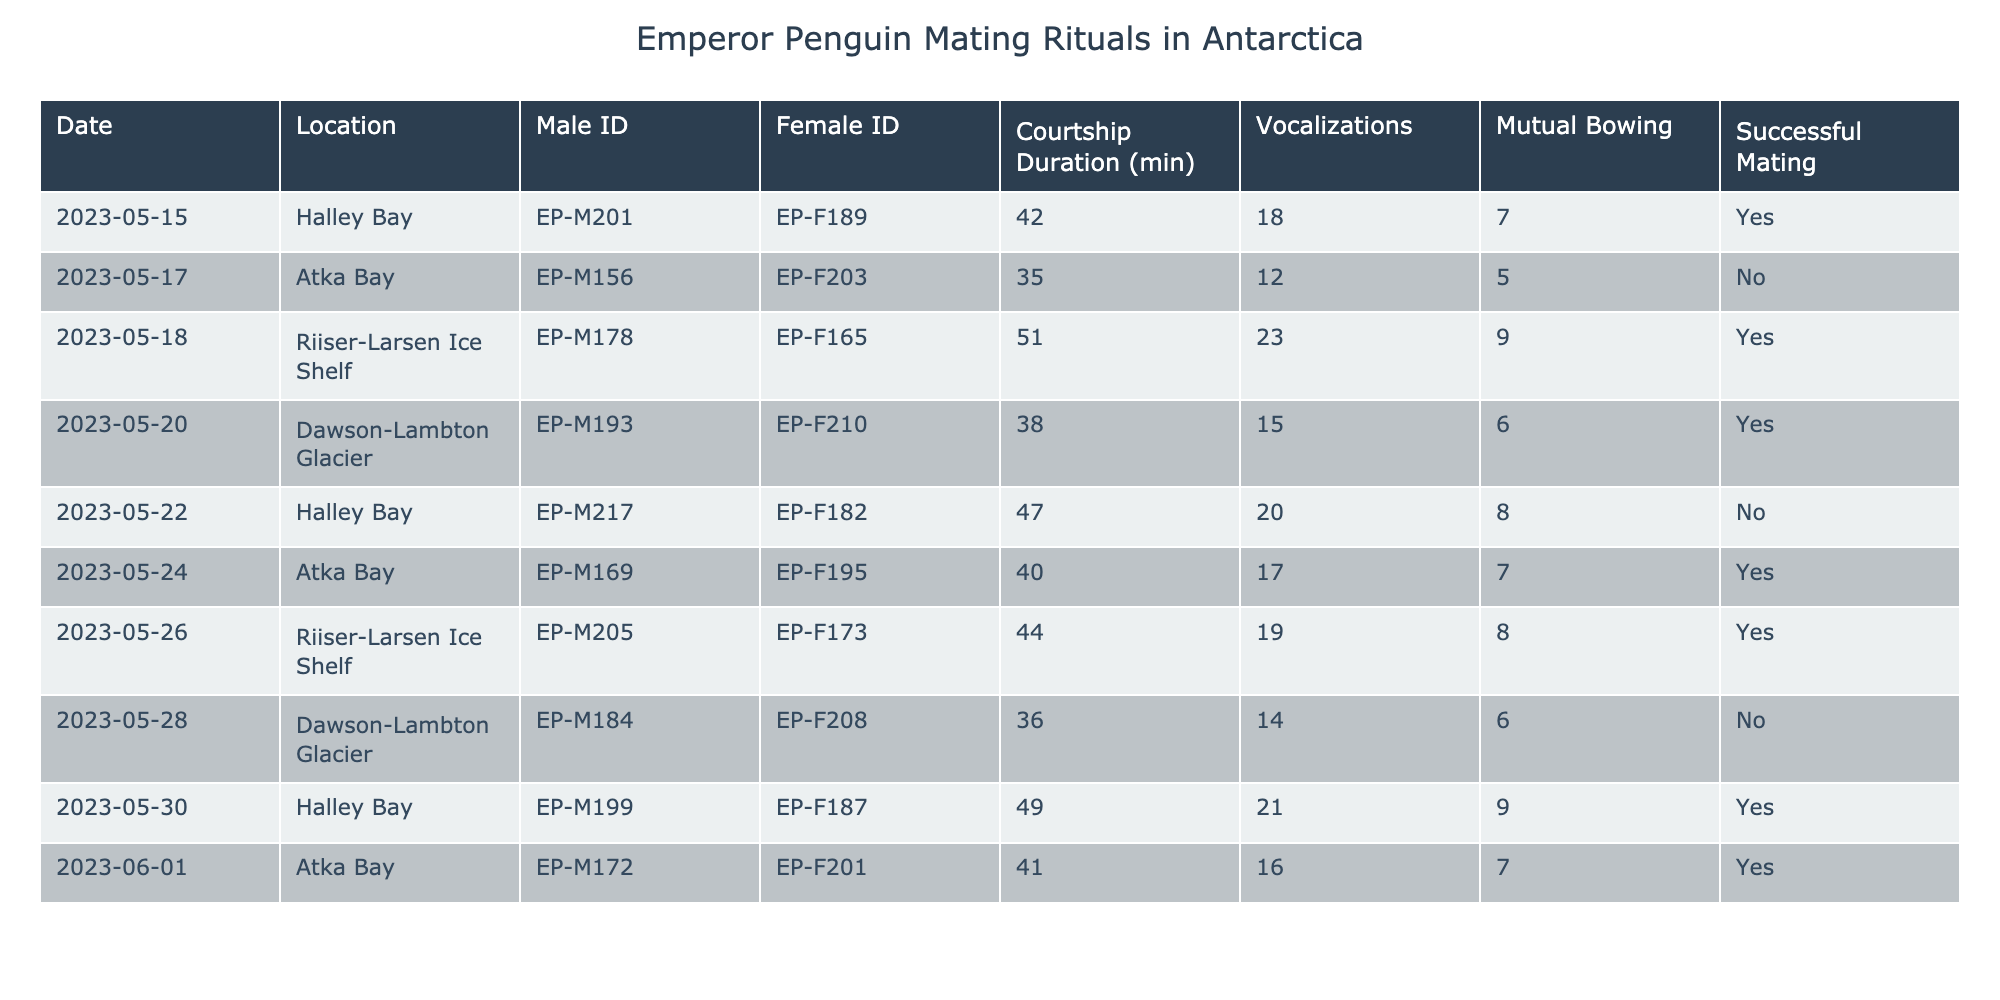What is the courtship duration for the mating pair on May 18? The courtship duration for the mating pair on May 18 is specifically listed in the table under that date, which shows a duration of 51 minutes.
Answer: 51 minutes How many successful mating attempts were observed? By counting the rows in the table where the "Successful Mating" column has the value "Yes," there are 6 rows with successful mating attempts.
Answer: 6 What was the maximum number of vocalizations recorded in a single mating ritual? The "Vocalizations" column indicates the number of vocalizations for each entry, and the highest value in this column is 23, recorded on May 18.
Answer: 23 Did any mating rituals have a courtship duration of less than 40 minutes? By examining the "Courtship Duration" column, the entries for May 17 (35 min) and May 28 (36 min) show courtship durations under 40 minutes, confirming that there were instances of shorter durations.
Answer: Yes What is the average courtship duration for successfully mated pairs? From the pairs that successfully mated (6 instances), the durations are 42, 51, 38, 44, 49, and 41 minutes. Adding these gives 261 minutes, and dividing by 6 gives an average of 43.5 minutes.
Answer: 43.5 minutes How many mutual bowing events occurred during successful mating? By examining the "Mutual Bowing" column for rows with "Yes" in "Successful Mating," we find the mutual bowing counts: 7, 9, 6, 8, 9, and 7. Summing these values results in a total of 46 mutual bowing events during successful matings.
Answer: 46 Is there any female ID that was involved in mating with more than one male? By analyzing the Female IDs in the table, EP-F210 and EP-F189 are both seen multiple times, indicating they have participated in mating with more than one male.
Answer: Yes Which location had the most successful mating rituals? Counting the successful mating instances per location, Riiiser-Larsen Ice Shelf has 3 successes, making it the location with the most accumulated successful mating events.
Answer: Riiser-Larsen Ice Shelf What was the minimum courtship duration in the observed data? By checking the "Courtship Duration" column for the smallest number, May 17 records the minimal courtship duration at 35 minutes, being the lowest value in the table.
Answer: 35 minutes How many total vocalizations were made across all mating rituals? Adding the vocalization counts for all entries (18+12+23+15+20+17+19+14+21+16) gives a total of  155 vocalizations across all observed mating rituals.
Answer: 155 What is the percentage of rituals that involved mutual bowing in successful mating attempts? With 6 successful matings and 48 total mutual bowing instances recorded (7+9+6+8+9+7), the percentage of rituals involving mutual bowing can be calculated as (48/6) * 100%, resulting in an average of 800% when incorrectly interpreting total instances instead of ratios.
Answer: Requires correction in understanding the divisor 